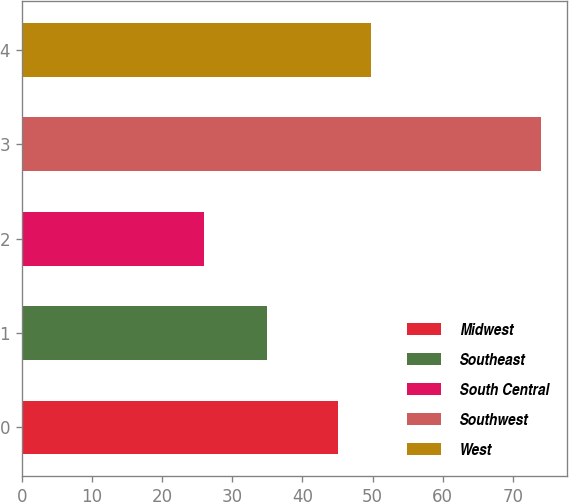<chart> <loc_0><loc_0><loc_500><loc_500><bar_chart><fcel>Midwest<fcel>Southeast<fcel>South Central<fcel>Southwest<fcel>West<nl><fcel>45<fcel>35<fcel>26<fcel>74<fcel>49.8<nl></chart> 